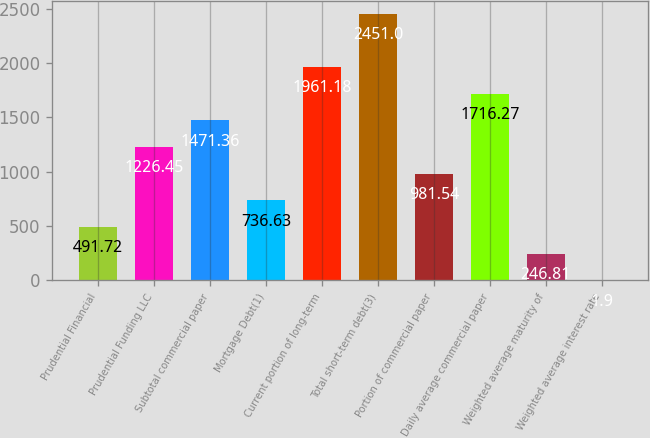<chart> <loc_0><loc_0><loc_500><loc_500><bar_chart><fcel>Prudential Financial<fcel>Prudential Funding LLC<fcel>Subtotal commercial paper<fcel>Mortgage Debt(1)<fcel>Current portion of long-term<fcel>Total short-term debt(3)<fcel>Portion of commercial paper<fcel>Daily average commercial paper<fcel>Weighted average maturity of<fcel>Weighted average interest rate<nl><fcel>491.72<fcel>1226.45<fcel>1471.36<fcel>736.63<fcel>1961.18<fcel>2451<fcel>981.54<fcel>1716.27<fcel>246.81<fcel>1.9<nl></chart> 